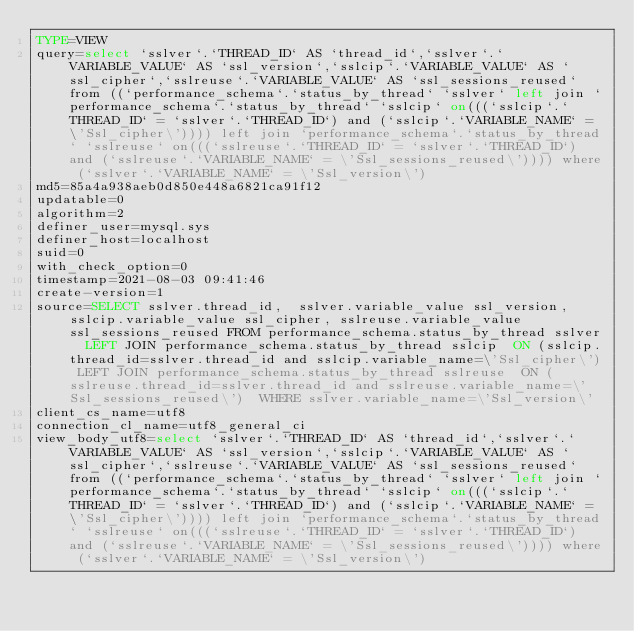Convert code to text. <code><loc_0><loc_0><loc_500><loc_500><_VisualBasic_>TYPE=VIEW
query=select `sslver`.`THREAD_ID` AS `thread_id`,`sslver`.`VARIABLE_VALUE` AS `ssl_version`,`sslcip`.`VARIABLE_VALUE` AS `ssl_cipher`,`sslreuse`.`VARIABLE_VALUE` AS `ssl_sessions_reused` from ((`performance_schema`.`status_by_thread` `sslver` left join `performance_schema`.`status_by_thread` `sslcip` on(((`sslcip`.`THREAD_ID` = `sslver`.`THREAD_ID`) and (`sslcip`.`VARIABLE_NAME` = \'Ssl_cipher\')))) left join `performance_schema`.`status_by_thread` `sslreuse` on(((`sslreuse`.`THREAD_ID` = `sslver`.`THREAD_ID`) and (`sslreuse`.`VARIABLE_NAME` = \'Ssl_sessions_reused\')))) where (`sslver`.`VARIABLE_NAME` = \'Ssl_version\')
md5=85a4a938aeb0d850e448a6821ca91f12
updatable=0
algorithm=2
definer_user=mysql.sys
definer_host=localhost
suid=0
with_check_option=0
timestamp=2021-08-03 09:41:46
create-version=1
source=SELECT sslver.thread_id,  sslver.variable_value ssl_version,  sslcip.variable_value ssl_cipher, sslreuse.variable_value ssl_sessions_reused FROM performance_schema.status_by_thread sslver  LEFT JOIN performance_schema.status_by_thread sslcip  ON (sslcip.thread_id=sslver.thread_id and sslcip.variable_name=\'Ssl_cipher\') LEFT JOIN performance_schema.status_by_thread sslreuse  ON (sslreuse.thread_id=sslver.thread_id and sslreuse.variable_name=\'Ssl_sessions_reused\')  WHERE sslver.variable_name=\'Ssl_version\'
client_cs_name=utf8
connection_cl_name=utf8_general_ci
view_body_utf8=select `sslver`.`THREAD_ID` AS `thread_id`,`sslver`.`VARIABLE_VALUE` AS `ssl_version`,`sslcip`.`VARIABLE_VALUE` AS `ssl_cipher`,`sslreuse`.`VARIABLE_VALUE` AS `ssl_sessions_reused` from ((`performance_schema`.`status_by_thread` `sslver` left join `performance_schema`.`status_by_thread` `sslcip` on(((`sslcip`.`THREAD_ID` = `sslver`.`THREAD_ID`) and (`sslcip`.`VARIABLE_NAME` = \'Ssl_cipher\')))) left join `performance_schema`.`status_by_thread` `sslreuse` on(((`sslreuse`.`THREAD_ID` = `sslver`.`THREAD_ID`) and (`sslreuse`.`VARIABLE_NAME` = \'Ssl_sessions_reused\')))) where (`sslver`.`VARIABLE_NAME` = \'Ssl_version\')
</code> 